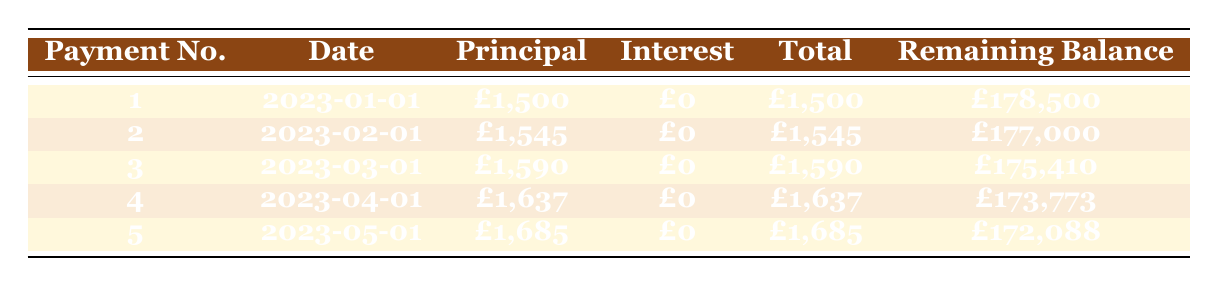What is the total payment for the first month? The total payment for the first month is listed in the table under the "Total" column for payment number 1, which is 1,500 pounds.
Answer: 1,500 pounds What is the remaining balance after the second payment? The remaining balance after the second payment can be found in the table under the "Remaining Balance" column for payment number 2, which shows 177,000 pounds.
Answer: 177,000 pounds How much did the monthly rent increase from month one to month two? The monthly rent for month one is 1,500 pounds (payment number 1), while for month two, it is 1,545 pounds (payment number 2). The increase is calculated as 1,545 - 1,500 = 45 pounds.
Answer: 45 pounds Is there any interest payment in the first five months? According to the table, the interest payment for all the payments listed is 0 pounds for the first five months.
Answer: Yes What is the sum of the principal payments for the first three months? The principal payments for the first three months are listed as 1,500 pounds (payment 1), 1,545 pounds (payment 2), and 1,590 pounds (payment 3). The sum is calculated as 1,500 + 1,545 + 1,590 = 4,635 pounds.
Answer: 4,635 pounds What is the average remaining balance after the first five payments? The remaining balances for the first five payments are 178,500 pounds (payment 1), 177,000 pounds (payment 2), 175,410 pounds (payment 3), 173,773 pounds (payment 4), and 172,088 pounds (payment 5). To find the average, add these together: 178,500 + 177,000 + 175,410 + 173,773 + 172,088 = 876,771 pounds, and divide by 5 (the number of payments): 876,771 / 5 = 175,354.2 pounds.
Answer: 175,354.2 pounds What was the total amount paid by the end of the fifth payment? To determine the total amount paid by the end of the fifth payment, add the total payments for each of the five months: 1,500 + 1,545 + 1,590 + 1,637 + 1,685 = 7,957 pounds.
Answer: 7,957 pounds Is the total remaining balance lower after the fourth payment compared to after the third payment? Yes, the remaining balance after the third payment is 175,410 pounds and after the fourth payment is 173,773 pounds. Since 173,773 is less than 175,410, the balance has decreased.
Answer: Yes 